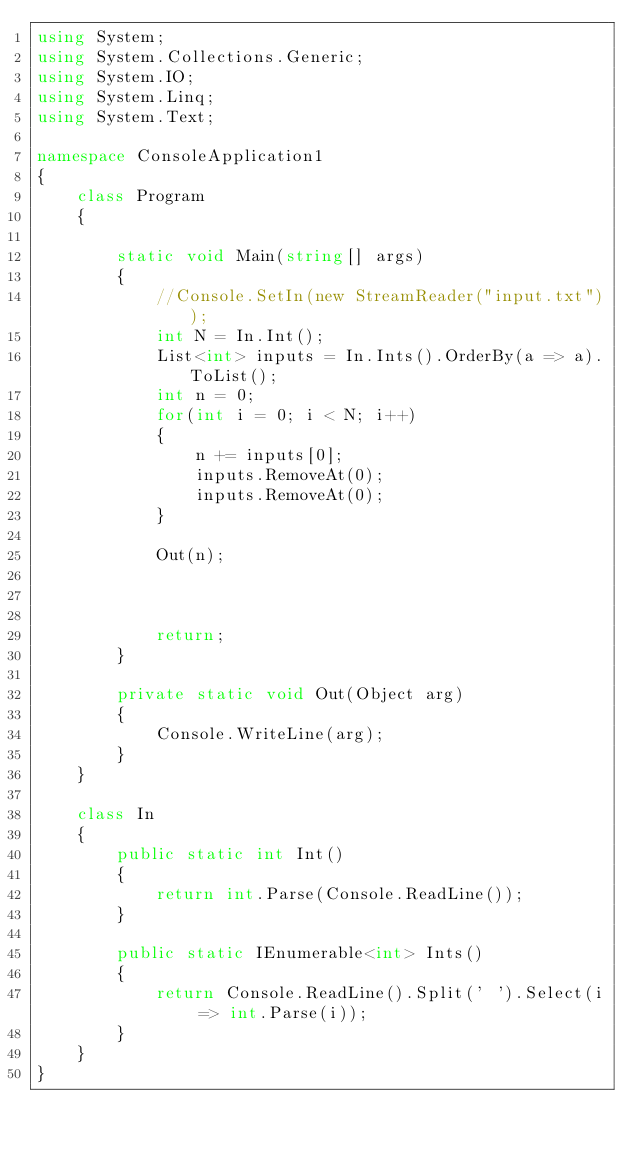Convert code to text. <code><loc_0><loc_0><loc_500><loc_500><_C#_>using System;
using System.Collections.Generic;
using System.IO;
using System.Linq;
using System.Text;

namespace ConsoleApplication1
{
    class Program
    {

        static void Main(string[] args)
        {
            //Console.SetIn(new StreamReader("input.txt"));
            int N = In.Int();
            List<int> inputs = In.Ints().OrderBy(a => a).ToList();
            int n = 0;
            for(int i = 0; i < N; i++)
            {
                n += inputs[0];
                inputs.RemoveAt(0);
                inputs.RemoveAt(0);
            }

            Out(n);



            return;
        } 

        private static void Out(Object arg)
        {
            Console.WriteLine(arg);
        }
    }

    class In
    {
        public static int Int()
        {
            return int.Parse(Console.ReadLine());
        }

        public static IEnumerable<int> Ints()
        {
            return Console.ReadLine().Split(' ').Select(i => int.Parse(i));
        }
    }
}
</code> 